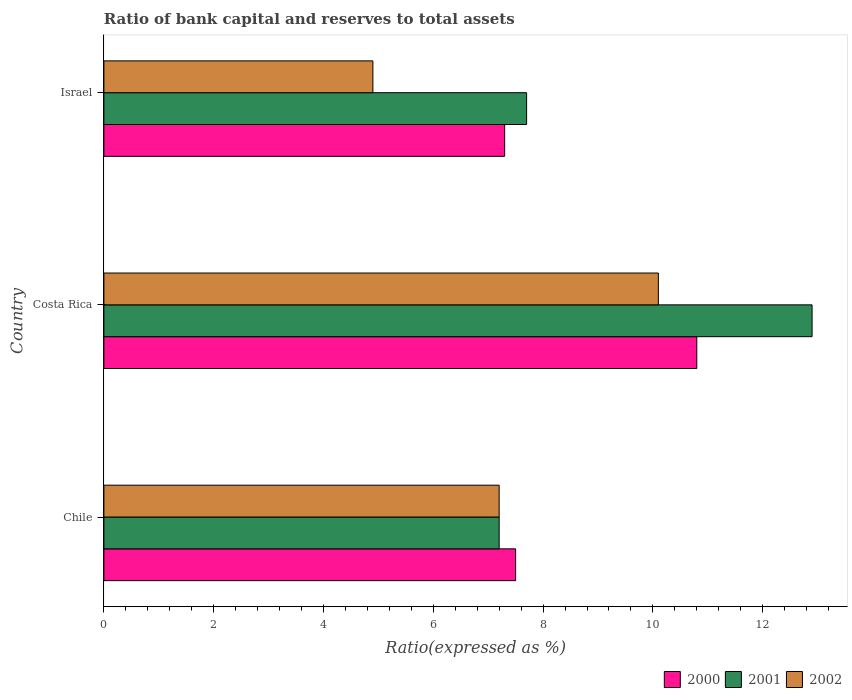How many different coloured bars are there?
Provide a succinct answer. 3. Are the number of bars on each tick of the Y-axis equal?
Make the answer very short. Yes. How many bars are there on the 3rd tick from the bottom?
Make the answer very short. 3. What is the label of the 1st group of bars from the top?
Offer a very short reply. Israel. Across all countries, what is the maximum ratio of bank capital and reserves to total assets in 2000?
Offer a very short reply. 10.8. What is the total ratio of bank capital and reserves to total assets in 2000 in the graph?
Offer a very short reply. 25.6. What is the difference between the ratio of bank capital and reserves to total assets in 2000 in Chile and that in Costa Rica?
Keep it short and to the point. -3.3. What is the difference between the ratio of bank capital and reserves to total assets in 2001 in Chile and the ratio of bank capital and reserves to total assets in 2000 in Costa Rica?
Provide a short and direct response. -3.6. What is the average ratio of bank capital and reserves to total assets in 2001 per country?
Offer a very short reply. 9.27. What is the difference between the ratio of bank capital and reserves to total assets in 2001 and ratio of bank capital and reserves to total assets in 2002 in Chile?
Offer a terse response. 0. In how many countries, is the ratio of bank capital and reserves to total assets in 2001 greater than 4.4 %?
Offer a very short reply. 3. What is the ratio of the ratio of bank capital and reserves to total assets in 2002 in Chile to that in Costa Rica?
Provide a short and direct response. 0.71. Is the ratio of bank capital and reserves to total assets in 2000 in Chile less than that in Israel?
Give a very brief answer. No. Is the difference between the ratio of bank capital and reserves to total assets in 2001 in Chile and Costa Rica greater than the difference between the ratio of bank capital and reserves to total assets in 2002 in Chile and Costa Rica?
Provide a succinct answer. No. What is the difference between the highest and the second highest ratio of bank capital and reserves to total assets in 2000?
Your answer should be very brief. 3.3. What is the difference between the highest and the lowest ratio of bank capital and reserves to total assets in 2002?
Your response must be concise. 5.2. In how many countries, is the ratio of bank capital and reserves to total assets in 2000 greater than the average ratio of bank capital and reserves to total assets in 2000 taken over all countries?
Provide a succinct answer. 1. What does the 1st bar from the bottom in Chile represents?
Your response must be concise. 2000. Is it the case that in every country, the sum of the ratio of bank capital and reserves to total assets in 2001 and ratio of bank capital and reserves to total assets in 2000 is greater than the ratio of bank capital and reserves to total assets in 2002?
Keep it short and to the point. Yes. How many countries are there in the graph?
Give a very brief answer. 3. Does the graph contain grids?
Offer a terse response. No. How many legend labels are there?
Offer a very short reply. 3. How are the legend labels stacked?
Keep it short and to the point. Horizontal. What is the title of the graph?
Your answer should be compact. Ratio of bank capital and reserves to total assets. What is the label or title of the X-axis?
Your answer should be compact. Ratio(expressed as %). What is the label or title of the Y-axis?
Provide a short and direct response. Country. What is the Ratio(expressed as %) of 2000 in Chile?
Ensure brevity in your answer.  7.5. What is the Ratio(expressed as %) of 2002 in Chile?
Give a very brief answer. 7.2. What is the Ratio(expressed as %) in 2000 in Israel?
Offer a very short reply. 7.3. What is the Ratio(expressed as %) of 2001 in Israel?
Ensure brevity in your answer.  7.7. What is the Ratio(expressed as %) in 2002 in Israel?
Ensure brevity in your answer.  4.9. Across all countries, what is the minimum Ratio(expressed as %) in 2002?
Make the answer very short. 4.9. What is the total Ratio(expressed as %) of 2000 in the graph?
Give a very brief answer. 25.6. What is the total Ratio(expressed as %) in 2001 in the graph?
Your response must be concise. 27.8. What is the difference between the Ratio(expressed as %) in 2000 in Chile and that in Israel?
Provide a short and direct response. 0.2. What is the difference between the Ratio(expressed as %) in 2002 in Costa Rica and that in Israel?
Make the answer very short. 5.2. What is the difference between the Ratio(expressed as %) of 2000 in Chile and the Ratio(expressed as %) of 2002 in Costa Rica?
Your response must be concise. -2.6. What is the difference between the Ratio(expressed as %) in 2000 in Chile and the Ratio(expressed as %) in 2001 in Israel?
Your response must be concise. -0.2. What is the difference between the Ratio(expressed as %) of 2001 in Chile and the Ratio(expressed as %) of 2002 in Israel?
Offer a very short reply. 2.3. What is the difference between the Ratio(expressed as %) of 2000 in Costa Rica and the Ratio(expressed as %) of 2001 in Israel?
Offer a terse response. 3.1. What is the difference between the Ratio(expressed as %) of 2000 in Costa Rica and the Ratio(expressed as %) of 2002 in Israel?
Your answer should be compact. 5.9. What is the average Ratio(expressed as %) in 2000 per country?
Offer a terse response. 8.53. What is the average Ratio(expressed as %) in 2001 per country?
Keep it short and to the point. 9.27. What is the difference between the Ratio(expressed as %) of 2000 and Ratio(expressed as %) of 2001 in Chile?
Offer a terse response. 0.3. What is the difference between the Ratio(expressed as %) in 2000 and Ratio(expressed as %) in 2002 in Chile?
Ensure brevity in your answer.  0.3. What is the difference between the Ratio(expressed as %) of 2001 and Ratio(expressed as %) of 2002 in Chile?
Provide a succinct answer. 0. What is the difference between the Ratio(expressed as %) of 2000 and Ratio(expressed as %) of 2001 in Israel?
Your answer should be very brief. -0.4. What is the difference between the Ratio(expressed as %) of 2000 and Ratio(expressed as %) of 2002 in Israel?
Provide a short and direct response. 2.4. What is the difference between the Ratio(expressed as %) in 2001 and Ratio(expressed as %) in 2002 in Israel?
Your response must be concise. 2.8. What is the ratio of the Ratio(expressed as %) in 2000 in Chile to that in Costa Rica?
Your response must be concise. 0.69. What is the ratio of the Ratio(expressed as %) of 2001 in Chile to that in Costa Rica?
Offer a very short reply. 0.56. What is the ratio of the Ratio(expressed as %) of 2002 in Chile to that in Costa Rica?
Your response must be concise. 0.71. What is the ratio of the Ratio(expressed as %) of 2000 in Chile to that in Israel?
Ensure brevity in your answer.  1.03. What is the ratio of the Ratio(expressed as %) of 2001 in Chile to that in Israel?
Keep it short and to the point. 0.94. What is the ratio of the Ratio(expressed as %) in 2002 in Chile to that in Israel?
Provide a short and direct response. 1.47. What is the ratio of the Ratio(expressed as %) of 2000 in Costa Rica to that in Israel?
Offer a terse response. 1.48. What is the ratio of the Ratio(expressed as %) in 2001 in Costa Rica to that in Israel?
Give a very brief answer. 1.68. What is the ratio of the Ratio(expressed as %) in 2002 in Costa Rica to that in Israel?
Offer a terse response. 2.06. What is the difference between the highest and the second highest Ratio(expressed as %) in 2000?
Offer a terse response. 3.3. What is the difference between the highest and the second highest Ratio(expressed as %) in 2002?
Keep it short and to the point. 2.9. What is the difference between the highest and the lowest Ratio(expressed as %) of 2002?
Give a very brief answer. 5.2. 